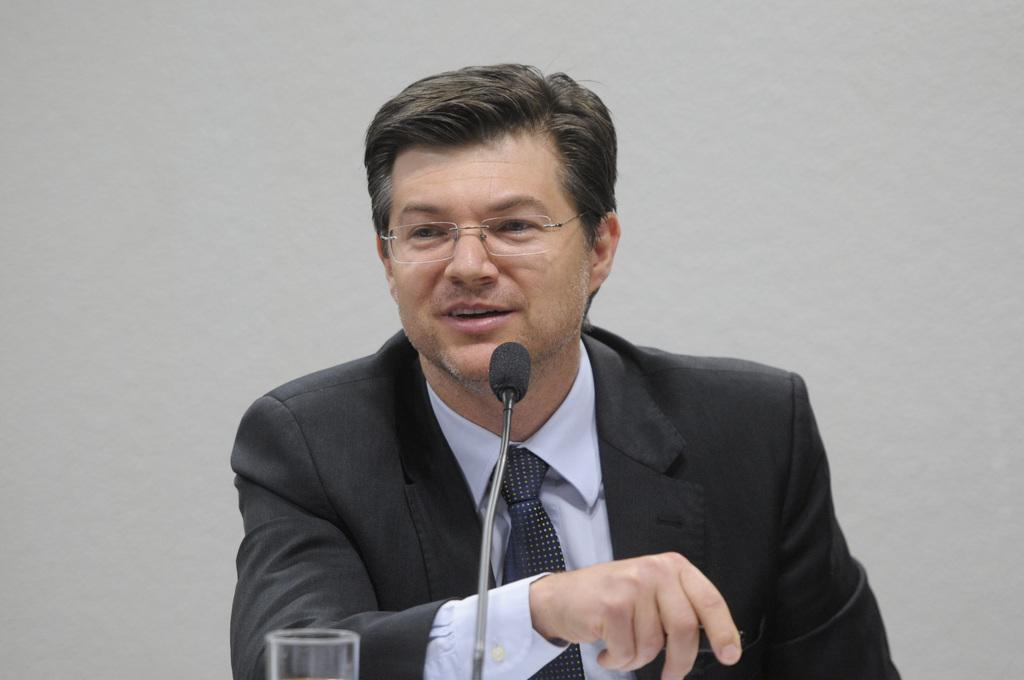Who is the main subject in the image? There is a man in the image. What is the man wearing on his upper body? The man is wearing a black jacket and a blue shirt. Is the man wearing any accessories? Yes, the man is wearing a tie. What is the man's posture in the image? The man is sitting. What can be seen on the man's face? The man has spectacles. What objects are in front of the man? There is a mic and a glass in front of the man. What is visible behind the man? There is a wall behind the man. What type of stone is the man standing on in the image? The image does not show the man standing on any stone; he is sitting on a chair. 